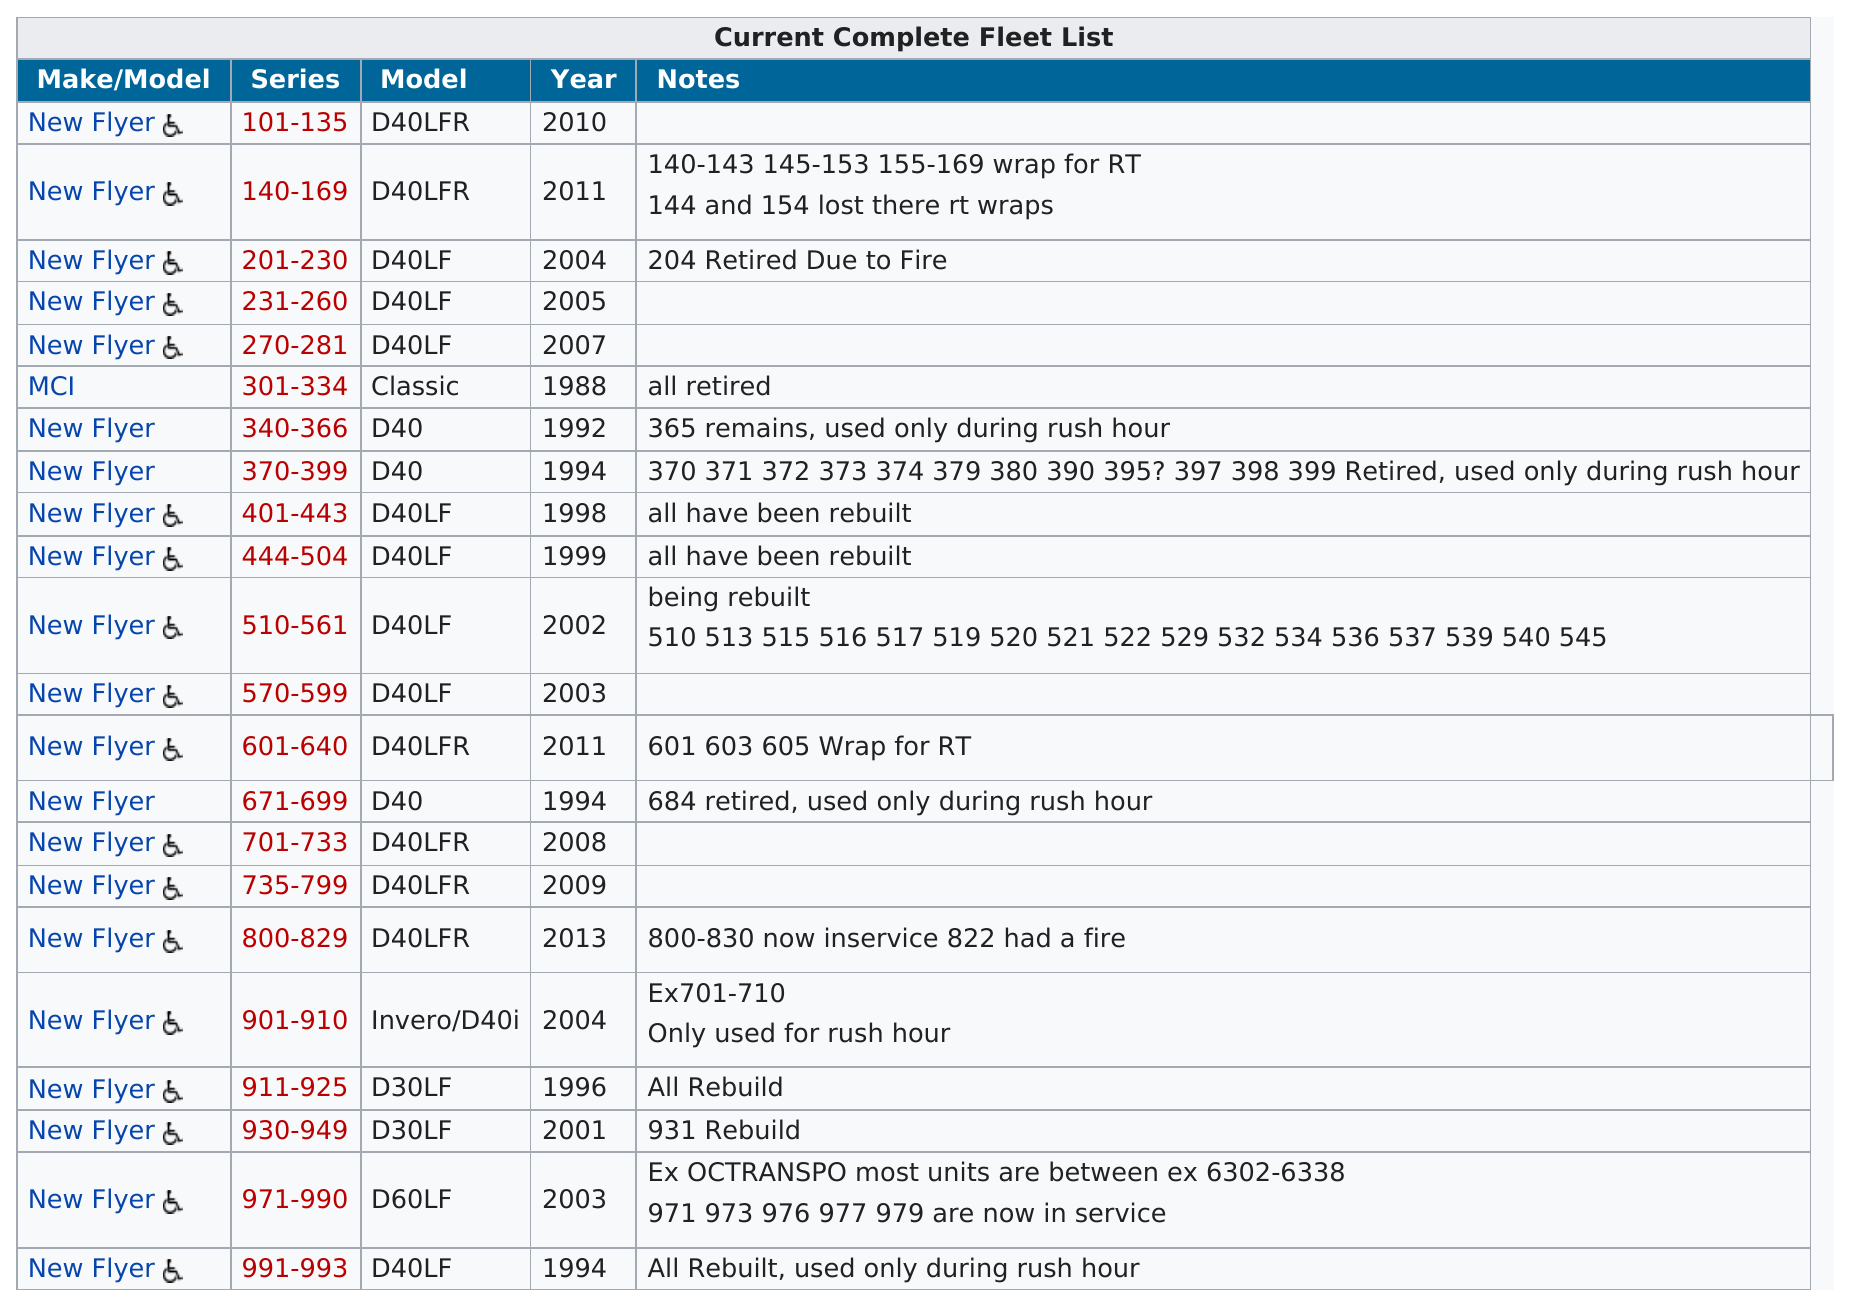Give some essential details in this illustration. The current fleet of buses has newer models in the range of 800-829. 